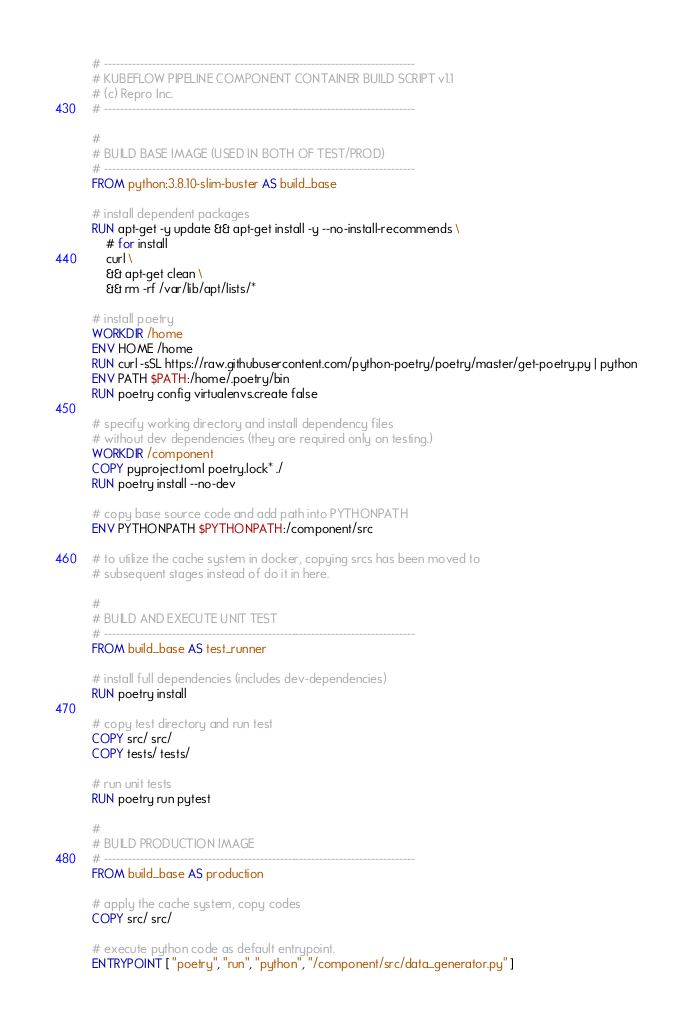<code> <loc_0><loc_0><loc_500><loc_500><_Dockerfile_># ------------------------------------------------------------------------------
# KUBEFLOW PIPELINE COMPONENT CONTAINER BUILD SCRIPT v1.1
# (c) Repro Inc.
# ------------------------------------------------------------------------------

#
# BUILD BASE IMAGE (USED IN BOTH OF TEST/PROD)
# ------------------------------------------------------------------------------
FROM python:3.8.10-slim-buster AS build_base

# install dependent packages
RUN apt-get -y update && apt-get install -y --no-install-recommends \
    # for install
    curl \
    && apt-get clean \
    && rm -rf /var/lib/apt/lists/*

# install poetry
WORKDIR /home
ENV HOME /home
RUN curl -sSL https://raw.githubusercontent.com/python-poetry/poetry/master/get-poetry.py | python
ENV PATH $PATH:/home/.poetry/bin
RUN poetry config virtualenvs.create false

# specify working directory and install dependency files
# without dev dependencies (they are required only on testing.)
WORKDIR /component
COPY pyproject.toml poetry.lock* ./
RUN poetry install --no-dev

# copy base source code and add path into PYTHONPATH
ENV PYTHONPATH $PYTHONPATH:/component/src

# to utilize the cache system in docker, copying srcs has been moved to 
# subsequent stages instead of do it in here.

#
# BUILD AND EXECUTE UNIT TEST
# ------------------------------------------------------------------------------
FROM build_base AS test_runner

# install full dependencies (includes dev-dependencies)
RUN poetry install

# copy test directory and run test
COPY src/ src/
COPY tests/ tests/

# run unit tests
RUN poetry run pytest

#
# BUILD PRODUCTION IMAGE
# ------------------------------------------------------------------------------
FROM build_base AS production

# apply the cache system, copy codes
COPY src/ src/

# execute python code as default entrypoint.
ENTRYPOINT [ "poetry", "run", "python", "/component/src/data_generator.py" ]</code> 